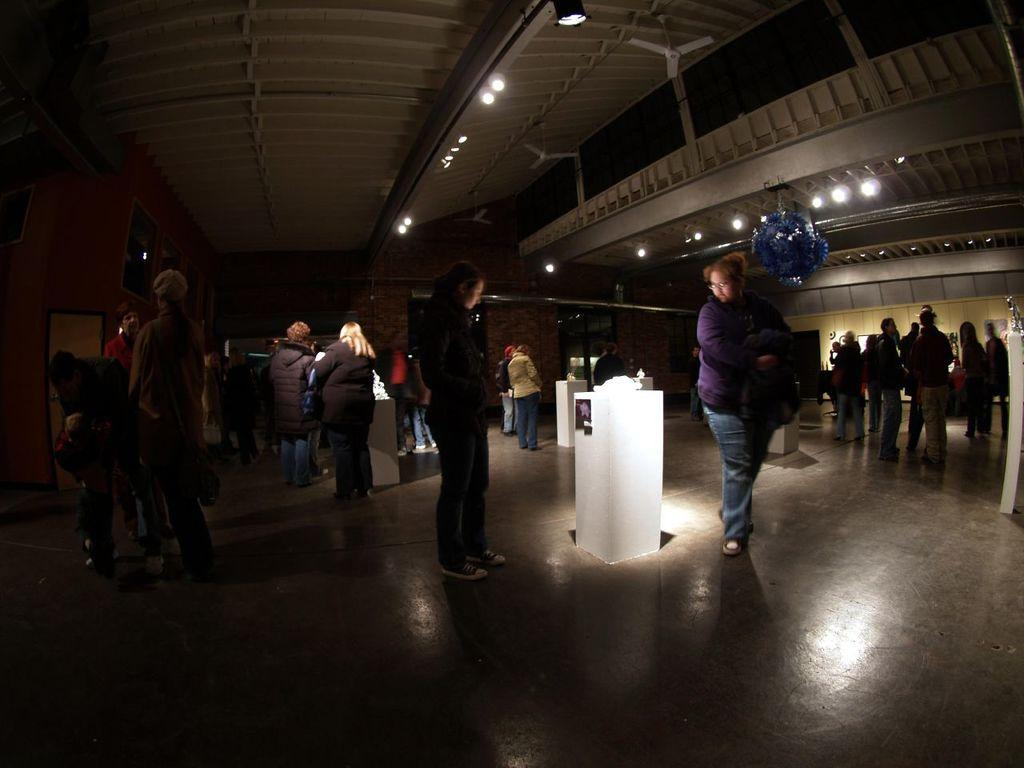How many people can be seen in the image? There are many people in the image. What objects are present in the image that are smaller in size? There are small poles in the image. What type of lighting is present in the image? There are lights on the ceiling in the image. What type of air circulation devices are present in the image? There are fans in the image. What type of decorative items are present on the wall? There are photo frames on the wall in the image. What type of architectural feature can be seen in the back of the image? There are doors visible in the back of the image. Can you see the ocean in the image? No, the ocean is not present in the image. Is there a zebra visible in the image? No, there is no zebra present in the image. 